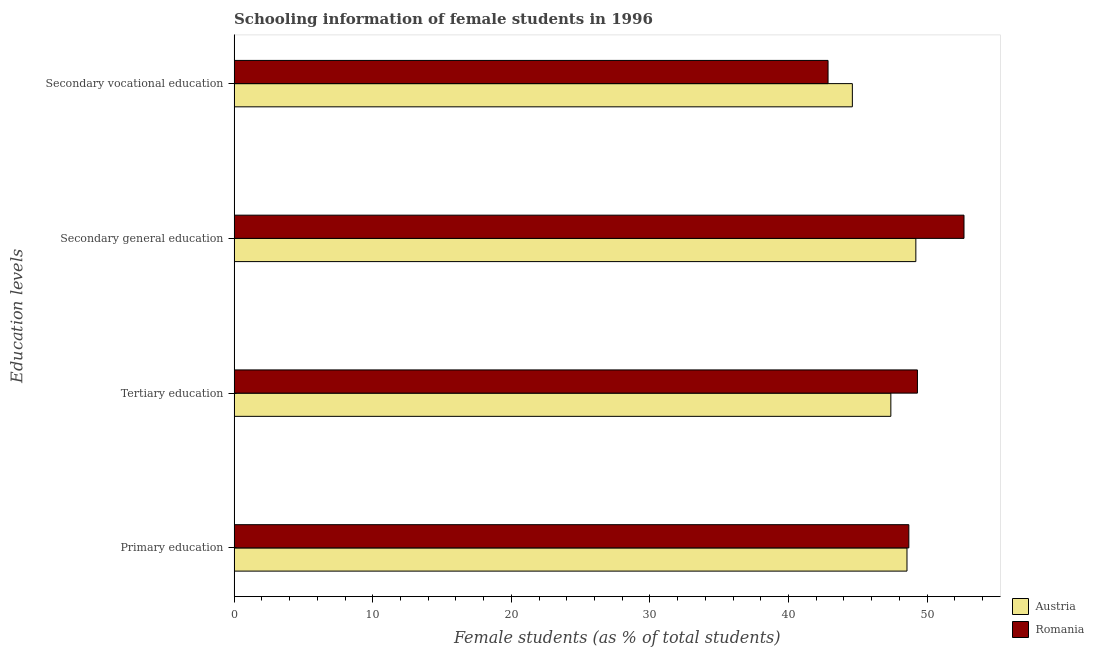What is the label of the 3rd group of bars from the top?
Offer a terse response. Tertiary education. What is the percentage of female students in secondary vocational education in Austria?
Provide a short and direct response. 44.61. Across all countries, what is the maximum percentage of female students in tertiary education?
Provide a short and direct response. 49.3. Across all countries, what is the minimum percentage of female students in secondary education?
Ensure brevity in your answer.  49.19. In which country was the percentage of female students in secondary vocational education maximum?
Provide a short and direct response. Austria. In which country was the percentage of female students in secondary vocational education minimum?
Your response must be concise. Romania. What is the total percentage of female students in secondary education in the graph?
Provide a short and direct response. 101.85. What is the difference between the percentage of female students in secondary vocational education in Romania and that in Austria?
Offer a terse response. -1.75. What is the difference between the percentage of female students in secondary education in Romania and the percentage of female students in secondary vocational education in Austria?
Ensure brevity in your answer.  8.05. What is the average percentage of female students in secondary vocational education per country?
Provide a succinct answer. 43.73. What is the difference between the percentage of female students in primary education and percentage of female students in tertiary education in Romania?
Make the answer very short. -0.62. In how many countries, is the percentage of female students in secondary education greater than 14 %?
Keep it short and to the point. 2. What is the ratio of the percentage of female students in secondary education in Austria to that in Romania?
Ensure brevity in your answer.  0.93. What is the difference between the highest and the second highest percentage of female students in tertiary education?
Your answer should be very brief. 1.92. What is the difference between the highest and the lowest percentage of female students in tertiary education?
Provide a succinct answer. 1.92. Is the sum of the percentage of female students in primary education in Austria and Romania greater than the maximum percentage of female students in secondary education across all countries?
Ensure brevity in your answer.  Yes. Is it the case that in every country, the sum of the percentage of female students in secondary education and percentage of female students in secondary vocational education is greater than the sum of percentage of female students in primary education and percentage of female students in tertiary education?
Provide a short and direct response. Yes. What does the 1st bar from the top in Tertiary education represents?
Provide a succinct answer. Romania. Are all the bars in the graph horizontal?
Offer a very short reply. Yes. How many countries are there in the graph?
Your response must be concise. 2. Does the graph contain any zero values?
Your answer should be compact. No. Where does the legend appear in the graph?
Provide a succinct answer. Bottom right. How many legend labels are there?
Your response must be concise. 2. What is the title of the graph?
Make the answer very short. Schooling information of female students in 1996. What is the label or title of the X-axis?
Your answer should be very brief. Female students (as % of total students). What is the label or title of the Y-axis?
Make the answer very short. Education levels. What is the Female students (as % of total students) in Austria in Primary education?
Offer a very short reply. 48.55. What is the Female students (as % of total students) in Romania in Primary education?
Your answer should be very brief. 48.68. What is the Female students (as % of total students) of Austria in Tertiary education?
Give a very brief answer. 47.38. What is the Female students (as % of total students) of Romania in Tertiary education?
Keep it short and to the point. 49.3. What is the Female students (as % of total students) in Austria in Secondary general education?
Your answer should be compact. 49.19. What is the Female students (as % of total students) of Romania in Secondary general education?
Offer a terse response. 52.66. What is the Female students (as % of total students) of Austria in Secondary vocational education?
Offer a terse response. 44.61. What is the Female students (as % of total students) in Romania in Secondary vocational education?
Offer a terse response. 42.85. Across all Education levels, what is the maximum Female students (as % of total students) of Austria?
Provide a succinct answer. 49.19. Across all Education levels, what is the maximum Female students (as % of total students) in Romania?
Make the answer very short. 52.66. Across all Education levels, what is the minimum Female students (as % of total students) in Austria?
Ensure brevity in your answer.  44.61. Across all Education levels, what is the minimum Female students (as % of total students) of Romania?
Make the answer very short. 42.85. What is the total Female students (as % of total students) in Austria in the graph?
Make the answer very short. 189.72. What is the total Female students (as % of total students) in Romania in the graph?
Your answer should be very brief. 193.49. What is the difference between the Female students (as % of total students) in Austria in Primary education and that in Tertiary education?
Your answer should be compact. 1.16. What is the difference between the Female students (as % of total students) in Romania in Primary education and that in Tertiary education?
Give a very brief answer. -0.62. What is the difference between the Female students (as % of total students) in Austria in Primary education and that in Secondary general education?
Provide a short and direct response. -0.64. What is the difference between the Female students (as % of total students) in Romania in Primary education and that in Secondary general education?
Ensure brevity in your answer.  -3.98. What is the difference between the Female students (as % of total students) of Austria in Primary education and that in Secondary vocational education?
Provide a succinct answer. 3.94. What is the difference between the Female students (as % of total students) of Romania in Primary education and that in Secondary vocational education?
Provide a short and direct response. 5.83. What is the difference between the Female students (as % of total students) in Austria in Tertiary education and that in Secondary general education?
Offer a terse response. -1.8. What is the difference between the Female students (as % of total students) in Romania in Tertiary education and that in Secondary general education?
Offer a very short reply. -3.36. What is the difference between the Female students (as % of total students) of Austria in Tertiary education and that in Secondary vocational education?
Offer a terse response. 2.78. What is the difference between the Female students (as % of total students) of Romania in Tertiary education and that in Secondary vocational education?
Offer a very short reply. 6.45. What is the difference between the Female students (as % of total students) in Austria in Secondary general education and that in Secondary vocational education?
Your response must be concise. 4.58. What is the difference between the Female students (as % of total students) of Romania in Secondary general education and that in Secondary vocational education?
Your answer should be compact. 9.81. What is the difference between the Female students (as % of total students) of Austria in Primary education and the Female students (as % of total students) of Romania in Tertiary education?
Provide a short and direct response. -0.75. What is the difference between the Female students (as % of total students) in Austria in Primary education and the Female students (as % of total students) in Romania in Secondary general education?
Your answer should be compact. -4.11. What is the difference between the Female students (as % of total students) of Austria in Primary education and the Female students (as % of total students) of Romania in Secondary vocational education?
Ensure brevity in your answer.  5.7. What is the difference between the Female students (as % of total students) of Austria in Tertiary education and the Female students (as % of total students) of Romania in Secondary general education?
Ensure brevity in your answer.  -5.28. What is the difference between the Female students (as % of total students) in Austria in Tertiary education and the Female students (as % of total students) in Romania in Secondary vocational education?
Your response must be concise. 4.53. What is the difference between the Female students (as % of total students) in Austria in Secondary general education and the Female students (as % of total students) in Romania in Secondary vocational education?
Your response must be concise. 6.33. What is the average Female students (as % of total students) of Austria per Education levels?
Your response must be concise. 47.43. What is the average Female students (as % of total students) of Romania per Education levels?
Your answer should be compact. 48.37. What is the difference between the Female students (as % of total students) in Austria and Female students (as % of total students) in Romania in Primary education?
Your answer should be very brief. -0.13. What is the difference between the Female students (as % of total students) in Austria and Female students (as % of total students) in Romania in Tertiary education?
Your answer should be very brief. -1.92. What is the difference between the Female students (as % of total students) in Austria and Female students (as % of total students) in Romania in Secondary general education?
Provide a succinct answer. -3.47. What is the difference between the Female students (as % of total students) of Austria and Female students (as % of total students) of Romania in Secondary vocational education?
Keep it short and to the point. 1.75. What is the ratio of the Female students (as % of total students) of Austria in Primary education to that in Tertiary education?
Your answer should be compact. 1.02. What is the ratio of the Female students (as % of total students) of Romania in Primary education to that in Tertiary education?
Ensure brevity in your answer.  0.99. What is the ratio of the Female students (as % of total students) in Romania in Primary education to that in Secondary general education?
Give a very brief answer. 0.92. What is the ratio of the Female students (as % of total students) in Austria in Primary education to that in Secondary vocational education?
Provide a succinct answer. 1.09. What is the ratio of the Female students (as % of total students) of Romania in Primary education to that in Secondary vocational education?
Your answer should be very brief. 1.14. What is the ratio of the Female students (as % of total students) of Austria in Tertiary education to that in Secondary general education?
Your answer should be compact. 0.96. What is the ratio of the Female students (as % of total students) in Romania in Tertiary education to that in Secondary general education?
Provide a succinct answer. 0.94. What is the ratio of the Female students (as % of total students) in Austria in Tertiary education to that in Secondary vocational education?
Ensure brevity in your answer.  1.06. What is the ratio of the Female students (as % of total students) in Romania in Tertiary education to that in Secondary vocational education?
Make the answer very short. 1.15. What is the ratio of the Female students (as % of total students) of Austria in Secondary general education to that in Secondary vocational education?
Offer a very short reply. 1.1. What is the ratio of the Female students (as % of total students) of Romania in Secondary general education to that in Secondary vocational education?
Ensure brevity in your answer.  1.23. What is the difference between the highest and the second highest Female students (as % of total students) of Austria?
Ensure brevity in your answer.  0.64. What is the difference between the highest and the second highest Female students (as % of total students) in Romania?
Provide a succinct answer. 3.36. What is the difference between the highest and the lowest Female students (as % of total students) of Austria?
Your response must be concise. 4.58. What is the difference between the highest and the lowest Female students (as % of total students) in Romania?
Make the answer very short. 9.81. 